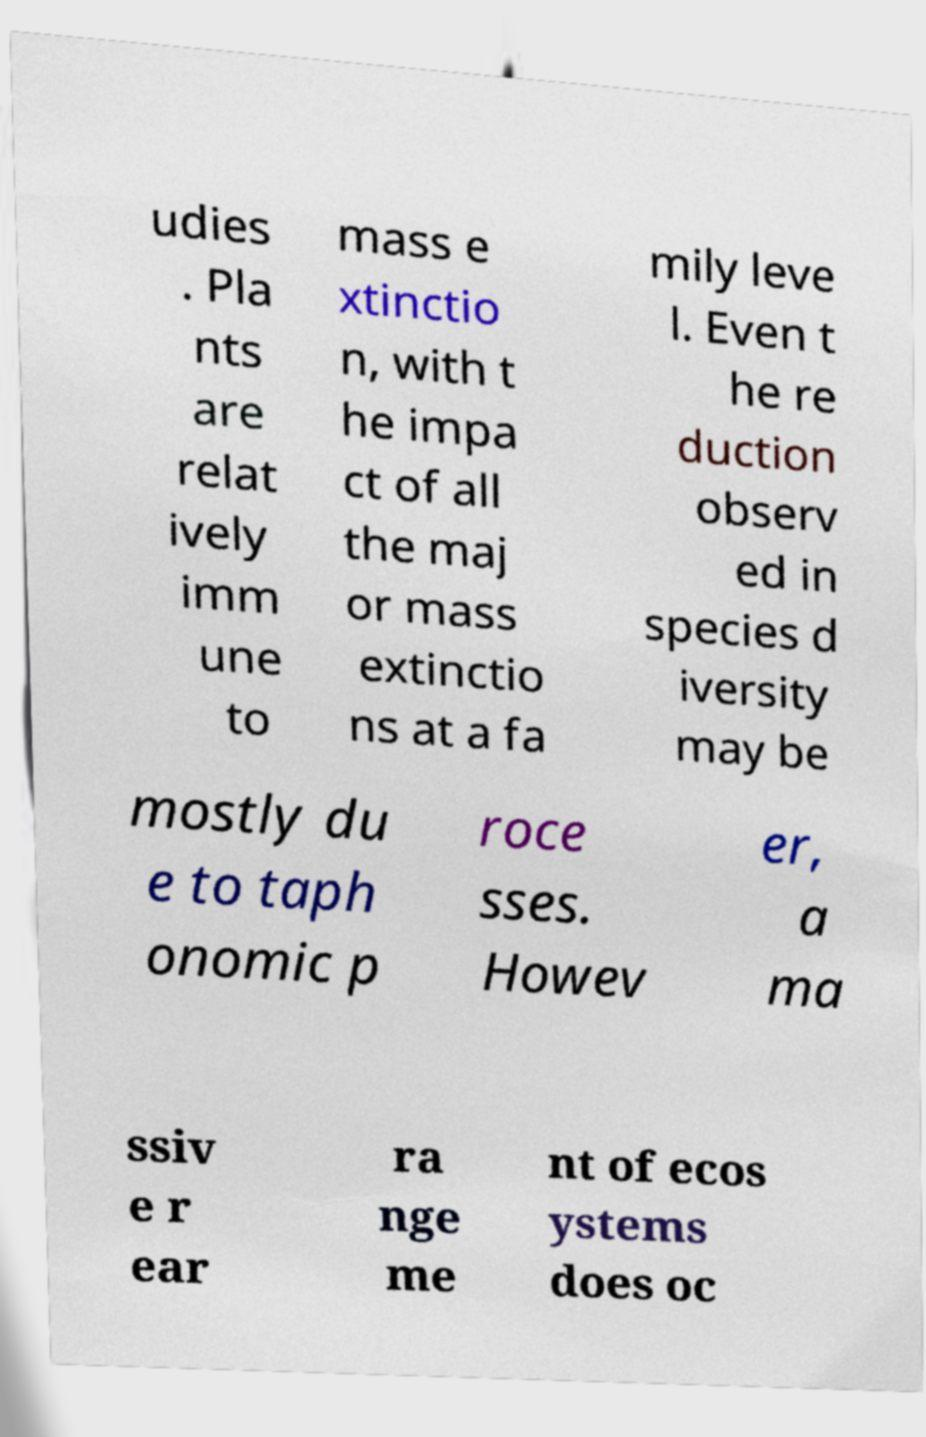Can you read and provide the text displayed in the image?This photo seems to have some interesting text. Can you extract and type it out for me? udies . Pla nts are relat ively imm une to mass e xtinctio n, with t he impa ct of all the maj or mass extinctio ns at a fa mily leve l. Even t he re duction observ ed in species d iversity may be mostly du e to taph onomic p roce sses. Howev er, a ma ssiv e r ear ra nge me nt of ecos ystems does oc 